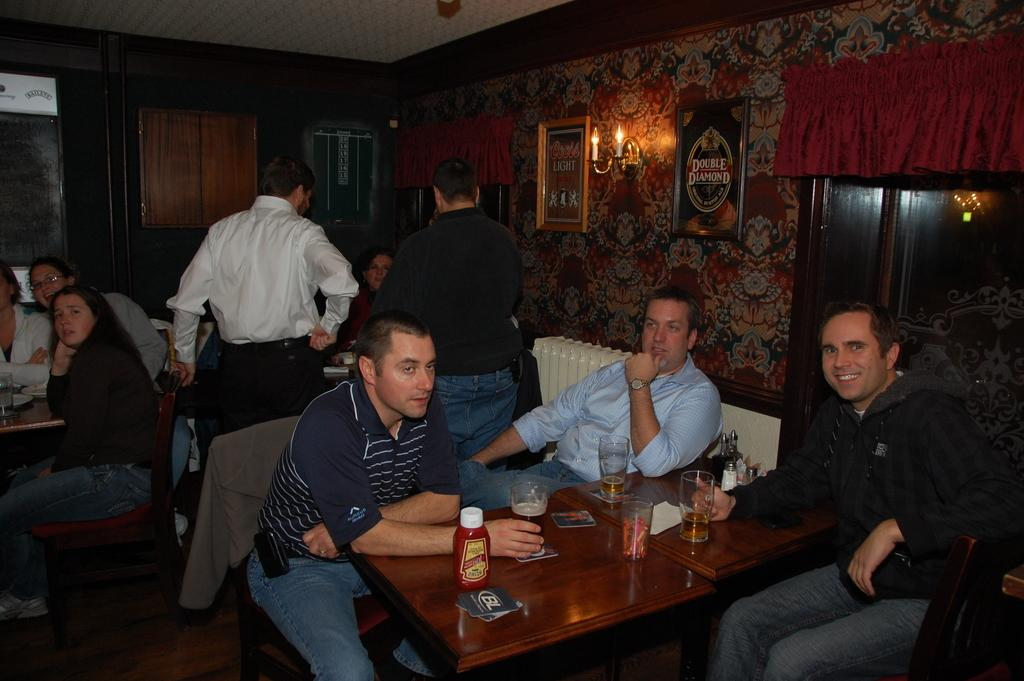How many people are sitting in chairs in the image? There are 3 men sitting in chairs and 2 women sitting on chairs on the left side, making a total of 5 people. What can be found on the table in the image? There are wine glasses on a table in the image. What is attached to the wall in the image? There is a lamp on the wall in the image. What type of horn can be seen on the table in the image? There is no horn present on the table in the image. How many fingers are visible on the women's hands in the image? The image does not show the fingers of the women's hands, so it cannot be determined from the image. 